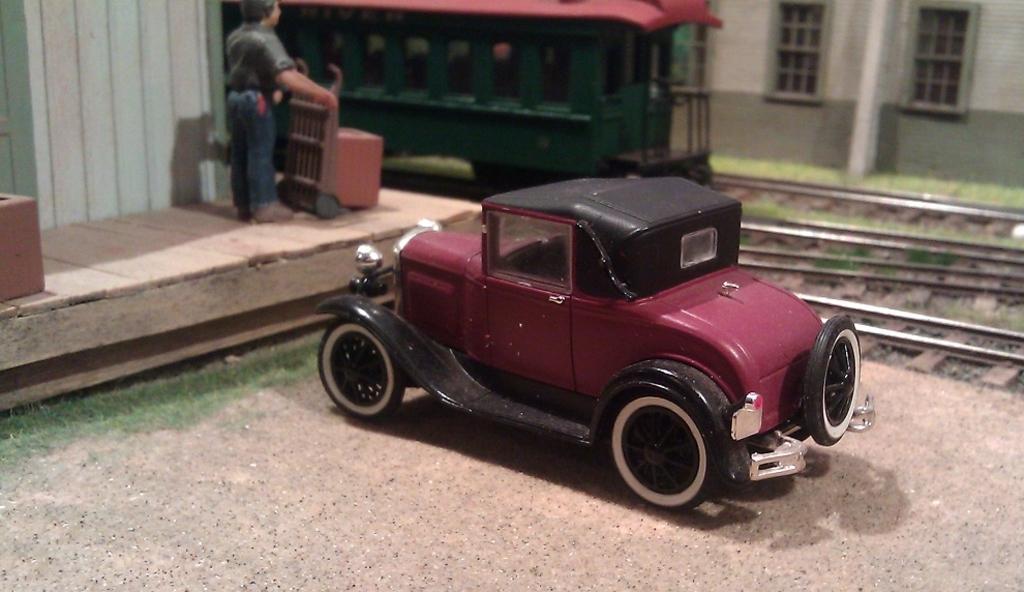Could you give a brief overview of what you see in this image? In this image in the front there is a toy car and on the left side there is a person. In the background there is a train and there is a building and there are railway tracks and there's grass on the ground. 